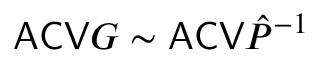<formula> <loc_0><loc_0><loc_500><loc_500>A C V G \sim A C V \hat { P } ^ { - 1 }</formula> 